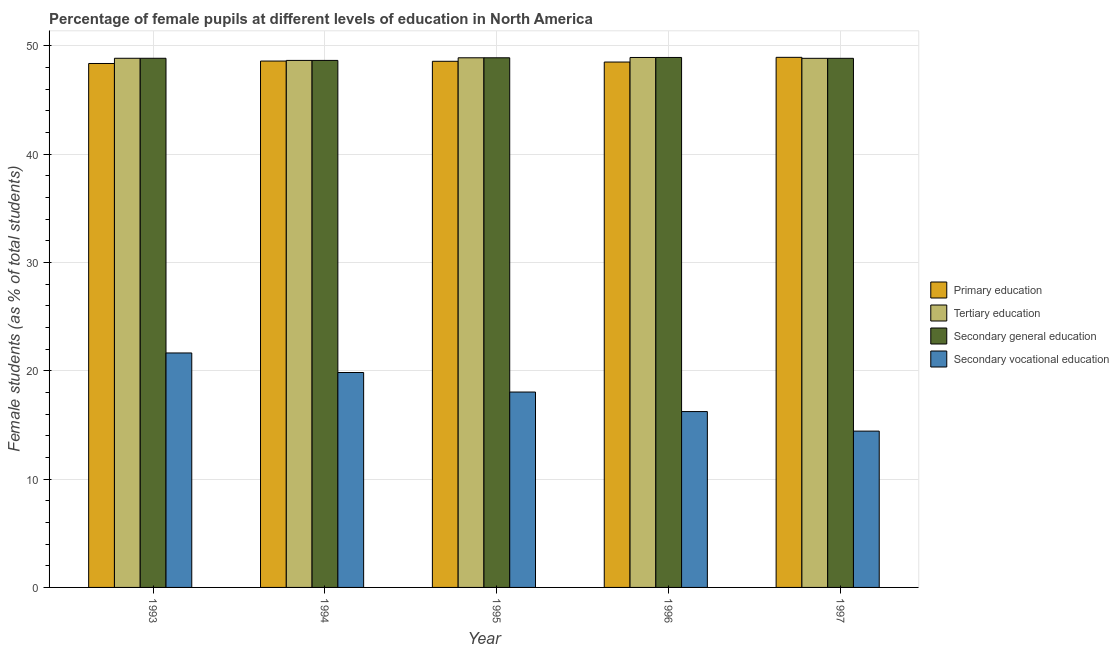How many different coloured bars are there?
Keep it short and to the point. 4. Are the number of bars per tick equal to the number of legend labels?
Give a very brief answer. Yes. Are the number of bars on each tick of the X-axis equal?
Offer a very short reply. Yes. How many bars are there on the 5th tick from the left?
Give a very brief answer. 4. How many bars are there on the 2nd tick from the right?
Your answer should be very brief. 4. What is the label of the 2nd group of bars from the left?
Give a very brief answer. 1994. In how many cases, is the number of bars for a given year not equal to the number of legend labels?
Your response must be concise. 0. What is the percentage of female students in secondary vocational education in 1994?
Your response must be concise. 19.84. Across all years, what is the maximum percentage of female students in secondary education?
Ensure brevity in your answer.  48.93. Across all years, what is the minimum percentage of female students in secondary education?
Provide a succinct answer. 48.66. What is the total percentage of female students in secondary education in the graph?
Give a very brief answer. 244.21. What is the difference between the percentage of female students in secondary vocational education in 1993 and that in 1994?
Provide a succinct answer. 1.8. What is the difference between the percentage of female students in secondary vocational education in 1995 and the percentage of female students in secondary education in 1996?
Provide a succinct answer. 1.8. What is the average percentage of female students in primary education per year?
Your response must be concise. 48.6. In the year 1993, what is the difference between the percentage of female students in secondary education and percentage of female students in primary education?
Offer a terse response. 0. What is the ratio of the percentage of female students in primary education in 1993 to that in 1995?
Your answer should be compact. 1. Is the difference between the percentage of female students in tertiary education in 1994 and 1997 greater than the difference between the percentage of female students in secondary vocational education in 1994 and 1997?
Offer a terse response. No. What is the difference between the highest and the second highest percentage of female students in secondary education?
Give a very brief answer. 0.03. What is the difference between the highest and the lowest percentage of female students in primary education?
Offer a very short reply. 0.57. What does the 4th bar from the left in 1997 represents?
Your response must be concise. Secondary vocational education. What does the 1st bar from the right in 1997 represents?
Ensure brevity in your answer.  Secondary vocational education. How many bars are there?
Ensure brevity in your answer.  20. How many years are there in the graph?
Give a very brief answer. 5. What is the title of the graph?
Offer a terse response. Percentage of female pupils at different levels of education in North America. Does "Korea" appear as one of the legend labels in the graph?
Keep it short and to the point. No. What is the label or title of the X-axis?
Keep it short and to the point. Year. What is the label or title of the Y-axis?
Make the answer very short. Female students (as % of total students). What is the Female students (as % of total students) in Primary education in 1993?
Your response must be concise. 48.38. What is the Female students (as % of total students) of Tertiary education in 1993?
Offer a terse response. 48.86. What is the Female students (as % of total students) in Secondary general education in 1993?
Make the answer very short. 48.86. What is the Female students (as % of total students) of Secondary vocational education in 1993?
Make the answer very short. 21.65. What is the Female students (as % of total students) in Primary education in 1994?
Your response must be concise. 48.6. What is the Female students (as % of total students) of Tertiary education in 1994?
Your response must be concise. 48.66. What is the Female students (as % of total students) in Secondary general education in 1994?
Make the answer very short. 48.66. What is the Female students (as % of total students) of Secondary vocational education in 1994?
Your answer should be compact. 19.84. What is the Female students (as % of total students) in Primary education in 1995?
Make the answer very short. 48.58. What is the Female students (as % of total students) in Tertiary education in 1995?
Offer a very short reply. 48.9. What is the Female students (as % of total students) in Secondary general education in 1995?
Make the answer very short. 48.9. What is the Female students (as % of total students) of Secondary vocational education in 1995?
Provide a short and direct response. 18.04. What is the Female students (as % of total students) in Primary education in 1996?
Offer a very short reply. 48.51. What is the Female students (as % of total students) in Tertiary education in 1996?
Give a very brief answer. 48.93. What is the Female students (as % of total students) of Secondary general education in 1996?
Offer a terse response. 48.93. What is the Female students (as % of total students) in Secondary vocational education in 1996?
Offer a very short reply. 16.24. What is the Female students (as % of total students) of Primary education in 1997?
Offer a very short reply. 48.95. What is the Female students (as % of total students) in Tertiary education in 1997?
Offer a terse response. 48.85. What is the Female students (as % of total students) in Secondary general education in 1997?
Offer a very short reply. 48.85. What is the Female students (as % of total students) in Secondary vocational education in 1997?
Keep it short and to the point. 14.43. Across all years, what is the maximum Female students (as % of total students) of Primary education?
Keep it short and to the point. 48.95. Across all years, what is the maximum Female students (as % of total students) of Tertiary education?
Keep it short and to the point. 48.93. Across all years, what is the maximum Female students (as % of total students) of Secondary general education?
Make the answer very short. 48.93. Across all years, what is the maximum Female students (as % of total students) in Secondary vocational education?
Your answer should be compact. 21.65. Across all years, what is the minimum Female students (as % of total students) of Primary education?
Your answer should be very brief. 48.38. Across all years, what is the minimum Female students (as % of total students) of Tertiary education?
Make the answer very short. 48.66. Across all years, what is the minimum Female students (as % of total students) in Secondary general education?
Your response must be concise. 48.66. Across all years, what is the minimum Female students (as % of total students) in Secondary vocational education?
Your response must be concise. 14.43. What is the total Female students (as % of total students) in Primary education in the graph?
Keep it short and to the point. 243.01. What is the total Female students (as % of total students) in Tertiary education in the graph?
Provide a succinct answer. 244.21. What is the total Female students (as % of total students) in Secondary general education in the graph?
Provide a succinct answer. 244.21. What is the total Female students (as % of total students) of Secondary vocational education in the graph?
Your response must be concise. 90.2. What is the difference between the Female students (as % of total students) in Primary education in 1993 and that in 1994?
Offer a very short reply. -0.23. What is the difference between the Female students (as % of total students) in Tertiary education in 1993 and that in 1994?
Provide a succinct answer. 0.2. What is the difference between the Female students (as % of total students) of Secondary general education in 1993 and that in 1994?
Your answer should be very brief. 0.2. What is the difference between the Female students (as % of total students) in Secondary vocational education in 1993 and that in 1994?
Your answer should be very brief. 1.8. What is the difference between the Female students (as % of total students) of Primary education in 1993 and that in 1995?
Offer a very short reply. -0.2. What is the difference between the Female students (as % of total students) of Tertiary education in 1993 and that in 1995?
Give a very brief answer. -0.05. What is the difference between the Female students (as % of total students) in Secondary general education in 1993 and that in 1995?
Offer a terse response. -0.05. What is the difference between the Female students (as % of total students) in Secondary vocational education in 1993 and that in 1995?
Your answer should be very brief. 3.61. What is the difference between the Female students (as % of total students) in Primary education in 1993 and that in 1996?
Your answer should be very brief. -0.13. What is the difference between the Female students (as % of total students) in Tertiary education in 1993 and that in 1996?
Your response must be concise. -0.07. What is the difference between the Female students (as % of total students) of Secondary general education in 1993 and that in 1996?
Give a very brief answer. -0.07. What is the difference between the Female students (as % of total students) of Secondary vocational education in 1993 and that in 1996?
Give a very brief answer. 5.41. What is the difference between the Female students (as % of total students) of Primary education in 1993 and that in 1997?
Keep it short and to the point. -0.57. What is the difference between the Female students (as % of total students) in Tertiary education in 1993 and that in 1997?
Keep it short and to the point. 0.01. What is the difference between the Female students (as % of total students) in Secondary general education in 1993 and that in 1997?
Make the answer very short. 0.01. What is the difference between the Female students (as % of total students) in Secondary vocational education in 1993 and that in 1997?
Offer a very short reply. 7.22. What is the difference between the Female students (as % of total students) of Primary education in 1994 and that in 1995?
Your answer should be very brief. 0.02. What is the difference between the Female students (as % of total students) of Tertiary education in 1994 and that in 1995?
Provide a short and direct response. -0.24. What is the difference between the Female students (as % of total students) of Secondary general education in 1994 and that in 1995?
Provide a succinct answer. -0.24. What is the difference between the Female students (as % of total students) in Secondary vocational education in 1994 and that in 1995?
Give a very brief answer. 1.8. What is the difference between the Female students (as % of total students) of Primary education in 1994 and that in 1996?
Offer a very short reply. 0.09. What is the difference between the Female students (as % of total students) in Tertiary education in 1994 and that in 1996?
Ensure brevity in your answer.  -0.27. What is the difference between the Female students (as % of total students) in Secondary general education in 1994 and that in 1996?
Keep it short and to the point. -0.27. What is the difference between the Female students (as % of total students) of Secondary vocational education in 1994 and that in 1996?
Provide a succinct answer. 3.61. What is the difference between the Female students (as % of total students) in Primary education in 1994 and that in 1997?
Your answer should be compact. -0.34. What is the difference between the Female students (as % of total students) of Tertiary education in 1994 and that in 1997?
Your answer should be compact. -0.19. What is the difference between the Female students (as % of total students) in Secondary general education in 1994 and that in 1997?
Your answer should be compact. -0.19. What is the difference between the Female students (as % of total students) of Secondary vocational education in 1994 and that in 1997?
Your answer should be very brief. 5.41. What is the difference between the Female students (as % of total students) in Primary education in 1995 and that in 1996?
Ensure brevity in your answer.  0.07. What is the difference between the Female students (as % of total students) in Tertiary education in 1995 and that in 1996?
Keep it short and to the point. -0.03. What is the difference between the Female students (as % of total students) of Secondary general education in 1995 and that in 1996?
Give a very brief answer. -0.03. What is the difference between the Female students (as % of total students) of Secondary vocational education in 1995 and that in 1996?
Your answer should be very brief. 1.8. What is the difference between the Female students (as % of total students) of Primary education in 1995 and that in 1997?
Your answer should be very brief. -0.37. What is the difference between the Female students (as % of total students) of Tertiary education in 1995 and that in 1997?
Your response must be concise. 0.05. What is the difference between the Female students (as % of total students) of Secondary general education in 1995 and that in 1997?
Provide a short and direct response. 0.05. What is the difference between the Female students (as % of total students) in Secondary vocational education in 1995 and that in 1997?
Give a very brief answer. 3.61. What is the difference between the Female students (as % of total students) of Primary education in 1996 and that in 1997?
Provide a succinct answer. -0.43. What is the difference between the Female students (as % of total students) in Tertiary education in 1996 and that in 1997?
Offer a terse response. 0.08. What is the difference between the Female students (as % of total students) in Secondary general education in 1996 and that in 1997?
Make the answer very short. 0.08. What is the difference between the Female students (as % of total students) of Secondary vocational education in 1996 and that in 1997?
Ensure brevity in your answer.  1.8. What is the difference between the Female students (as % of total students) of Primary education in 1993 and the Female students (as % of total students) of Tertiary education in 1994?
Provide a succinct answer. -0.28. What is the difference between the Female students (as % of total students) of Primary education in 1993 and the Female students (as % of total students) of Secondary general education in 1994?
Your response must be concise. -0.28. What is the difference between the Female students (as % of total students) of Primary education in 1993 and the Female students (as % of total students) of Secondary vocational education in 1994?
Offer a very short reply. 28.53. What is the difference between the Female students (as % of total students) in Tertiary education in 1993 and the Female students (as % of total students) in Secondary general education in 1994?
Your answer should be very brief. 0.2. What is the difference between the Female students (as % of total students) in Tertiary education in 1993 and the Female students (as % of total students) in Secondary vocational education in 1994?
Your answer should be very brief. 29.01. What is the difference between the Female students (as % of total students) in Secondary general education in 1993 and the Female students (as % of total students) in Secondary vocational education in 1994?
Provide a succinct answer. 29.01. What is the difference between the Female students (as % of total students) of Primary education in 1993 and the Female students (as % of total students) of Tertiary education in 1995?
Offer a very short reply. -0.53. What is the difference between the Female students (as % of total students) of Primary education in 1993 and the Female students (as % of total students) of Secondary general education in 1995?
Offer a terse response. -0.53. What is the difference between the Female students (as % of total students) in Primary education in 1993 and the Female students (as % of total students) in Secondary vocational education in 1995?
Give a very brief answer. 30.34. What is the difference between the Female students (as % of total students) in Tertiary education in 1993 and the Female students (as % of total students) in Secondary general education in 1995?
Provide a short and direct response. -0.05. What is the difference between the Female students (as % of total students) in Tertiary education in 1993 and the Female students (as % of total students) in Secondary vocational education in 1995?
Keep it short and to the point. 30.82. What is the difference between the Female students (as % of total students) in Secondary general education in 1993 and the Female students (as % of total students) in Secondary vocational education in 1995?
Offer a terse response. 30.82. What is the difference between the Female students (as % of total students) of Primary education in 1993 and the Female students (as % of total students) of Tertiary education in 1996?
Your response must be concise. -0.56. What is the difference between the Female students (as % of total students) of Primary education in 1993 and the Female students (as % of total students) of Secondary general education in 1996?
Keep it short and to the point. -0.56. What is the difference between the Female students (as % of total students) of Primary education in 1993 and the Female students (as % of total students) of Secondary vocational education in 1996?
Your response must be concise. 32.14. What is the difference between the Female students (as % of total students) of Tertiary education in 1993 and the Female students (as % of total students) of Secondary general education in 1996?
Your response must be concise. -0.07. What is the difference between the Female students (as % of total students) of Tertiary education in 1993 and the Female students (as % of total students) of Secondary vocational education in 1996?
Offer a terse response. 32.62. What is the difference between the Female students (as % of total students) of Secondary general education in 1993 and the Female students (as % of total students) of Secondary vocational education in 1996?
Give a very brief answer. 32.62. What is the difference between the Female students (as % of total students) of Primary education in 1993 and the Female students (as % of total students) of Tertiary education in 1997?
Make the answer very short. -0.48. What is the difference between the Female students (as % of total students) of Primary education in 1993 and the Female students (as % of total students) of Secondary general education in 1997?
Your response must be concise. -0.48. What is the difference between the Female students (as % of total students) in Primary education in 1993 and the Female students (as % of total students) in Secondary vocational education in 1997?
Ensure brevity in your answer.  33.94. What is the difference between the Female students (as % of total students) in Tertiary education in 1993 and the Female students (as % of total students) in Secondary general education in 1997?
Your response must be concise. 0.01. What is the difference between the Female students (as % of total students) in Tertiary education in 1993 and the Female students (as % of total students) in Secondary vocational education in 1997?
Offer a terse response. 34.43. What is the difference between the Female students (as % of total students) of Secondary general education in 1993 and the Female students (as % of total students) of Secondary vocational education in 1997?
Offer a terse response. 34.43. What is the difference between the Female students (as % of total students) of Primary education in 1994 and the Female students (as % of total students) of Tertiary education in 1995?
Make the answer very short. -0.3. What is the difference between the Female students (as % of total students) of Primary education in 1994 and the Female students (as % of total students) of Secondary general education in 1995?
Provide a short and direct response. -0.3. What is the difference between the Female students (as % of total students) of Primary education in 1994 and the Female students (as % of total students) of Secondary vocational education in 1995?
Provide a succinct answer. 30.56. What is the difference between the Female students (as % of total students) of Tertiary education in 1994 and the Female students (as % of total students) of Secondary general education in 1995?
Ensure brevity in your answer.  -0.24. What is the difference between the Female students (as % of total students) of Tertiary education in 1994 and the Female students (as % of total students) of Secondary vocational education in 1995?
Ensure brevity in your answer.  30.62. What is the difference between the Female students (as % of total students) of Secondary general education in 1994 and the Female students (as % of total students) of Secondary vocational education in 1995?
Your response must be concise. 30.62. What is the difference between the Female students (as % of total students) of Primary education in 1994 and the Female students (as % of total students) of Tertiary education in 1996?
Make the answer very short. -0.33. What is the difference between the Female students (as % of total students) of Primary education in 1994 and the Female students (as % of total students) of Secondary general education in 1996?
Offer a terse response. -0.33. What is the difference between the Female students (as % of total students) of Primary education in 1994 and the Female students (as % of total students) of Secondary vocational education in 1996?
Ensure brevity in your answer.  32.37. What is the difference between the Female students (as % of total students) of Tertiary education in 1994 and the Female students (as % of total students) of Secondary general education in 1996?
Keep it short and to the point. -0.27. What is the difference between the Female students (as % of total students) of Tertiary education in 1994 and the Female students (as % of total students) of Secondary vocational education in 1996?
Provide a succinct answer. 32.42. What is the difference between the Female students (as % of total students) of Secondary general education in 1994 and the Female students (as % of total students) of Secondary vocational education in 1996?
Provide a succinct answer. 32.42. What is the difference between the Female students (as % of total students) in Primary education in 1994 and the Female students (as % of total students) in Tertiary education in 1997?
Provide a short and direct response. -0.25. What is the difference between the Female students (as % of total students) of Primary education in 1994 and the Female students (as % of total students) of Secondary general education in 1997?
Give a very brief answer. -0.25. What is the difference between the Female students (as % of total students) of Primary education in 1994 and the Female students (as % of total students) of Secondary vocational education in 1997?
Provide a short and direct response. 34.17. What is the difference between the Female students (as % of total students) in Tertiary education in 1994 and the Female students (as % of total students) in Secondary general education in 1997?
Keep it short and to the point. -0.19. What is the difference between the Female students (as % of total students) in Tertiary education in 1994 and the Female students (as % of total students) in Secondary vocational education in 1997?
Your answer should be compact. 34.23. What is the difference between the Female students (as % of total students) in Secondary general education in 1994 and the Female students (as % of total students) in Secondary vocational education in 1997?
Keep it short and to the point. 34.23. What is the difference between the Female students (as % of total students) in Primary education in 1995 and the Female students (as % of total students) in Tertiary education in 1996?
Your response must be concise. -0.35. What is the difference between the Female students (as % of total students) of Primary education in 1995 and the Female students (as % of total students) of Secondary general education in 1996?
Ensure brevity in your answer.  -0.35. What is the difference between the Female students (as % of total students) of Primary education in 1995 and the Female students (as % of total students) of Secondary vocational education in 1996?
Ensure brevity in your answer.  32.34. What is the difference between the Female students (as % of total students) of Tertiary education in 1995 and the Female students (as % of total students) of Secondary general education in 1996?
Provide a succinct answer. -0.03. What is the difference between the Female students (as % of total students) in Tertiary education in 1995 and the Female students (as % of total students) in Secondary vocational education in 1996?
Offer a terse response. 32.67. What is the difference between the Female students (as % of total students) of Secondary general education in 1995 and the Female students (as % of total students) of Secondary vocational education in 1996?
Make the answer very short. 32.67. What is the difference between the Female students (as % of total students) of Primary education in 1995 and the Female students (as % of total students) of Tertiary education in 1997?
Give a very brief answer. -0.27. What is the difference between the Female students (as % of total students) of Primary education in 1995 and the Female students (as % of total students) of Secondary general education in 1997?
Keep it short and to the point. -0.27. What is the difference between the Female students (as % of total students) of Primary education in 1995 and the Female students (as % of total students) of Secondary vocational education in 1997?
Make the answer very short. 34.15. What is the difference between the Female students (as % of total students) in Tertiary education in 1995 and the Female students (as % of total students) in Secondary general education in 1997?
Offer a very short reply. 0.05. What is the difference between the Female students (as % of total students) of Tertiary education in 1995 and the Female students (as % of total students) of Secondary vocational education in 1997?
Your answer should be very brief. 34.47. What is the difference between the Female students (as % of total students) of Secondary general education in 1995 and the Female students (as % of total students) of Secondary vocational education in 1997?
Your response must be concise. 34.47. What is the difference between the Female students (as % of total students) of Primary education in 1996 and the Female students (as % of total students) of Tertiary education in 1997?
Make the answer very short. -0.34. What is the difference between the Female students (as % of total students) of Primary education in 1996 and the Female students (as % of total students) of Secondary general education in 1997?
Give a very brief answer. -0.34. What is the difference between the Female students (as % of total students) in Primary education in 1996 and the Female students (as % of total students) in Secondary vocational education in 1997?
Offer a very short reply. 34.08. What is the difference between the Female students (as % of total students) of Tertiary education in 1996 and the Female students (as % of total students) of Secondary general education in 1997?
Give a very brief answer. 0.08. What is the difference between the Female students (as % of total students) in Tertiary education in 1996 and the Female students (as % of total students) in Secondary vocational education in 1997?
Your answer should be very brief. 34.5. What is the difference between the Female students (as % of total students) of Secondary general education in 1996 and the Female students (as % of total students) of Secondary vocational education in 1997?
Give a very brief answer. 34.5. What is the average Female students (as % of total students) of Primary education per year?
Your answer should be very brief. 48.6. What is the average Female students (as % of total students) of Tertiary education per year?
Make the answer very short. 48.84. What is the average Female students (as % of total students) of Secondary general education per year?
Keep it short and to the point. 48.84. What is the average Female students (as % of total students) of Secondary vocational education per year?
Provide a short and direct response. 18.04. In the year 1993, what is the difference between the Female students (as % of total students) in Primary education and Female students (as % of total students) in Tertiary education?
Your answer should be very brief. -0.48. In the year 1993, what is the difference between the Female students (as % of total students) of Primary education and Female students (as % of total students) of Secondary general education?
Make the answer very short. -0.48. In the year 1993, what is the difference between the Female students (as % of total students) in Primary education and Female students (as % of total students) in Secondary vocational education?
Offer a terse response. 26.73. In the year 1993, what is the difference between the Female students (as % of total students) of Tertiary education and Female students (as % of total students) of Secondary general education?
Give a very brief answer. -0. In the year 1993, what is the difference between the Female students (as % of total students) of Tertiary education and Female students (as % of total students) of Secondary vocational education?
Keep it short and to the point. 27.21. In the year 1993, what is the difference between the Female students (as % of total students) in Secondary general education and Female students (as % of total students) in Secondary vocational education?
Offer a very short reply. 27.21. In the year 1994, what is the difference between the Female students (as % of total students) in Primary education and Female students (as % of total students) in Tertiary education?
Make the answer very short. -0.06. In the year 1994, what is the difference between the Female students (as % of total students) in Primary education and Female students (as % of total students) in Secondary general education?
Provide a short and direct response. -0.06. In the year 1994, what is the difference between the Female students (as % of total students) of Primary education and Female students (as % of total students) of Secondary vocational education?
Ensure brevity in your answer.  28.76. In the year 1994, what is the difference between the Female students (as % of total students) in Tertiary education and Female students (as % of total students) in Secondary general education?
Ensure brevity in your answer.  -0. In the year 1994, what is the difference between the Female students (as % of total students) in Tertiary education and Female students (as % of total students) in Secondary vocational education?
Your response must be concise. 28.82. In the year 1994, what is the difference between the Female students (as % of total students) in Secondary general education and Female students (as % of total students) in Secondary vocational education?
Make the answer very short. 28.82. In the year 1995, what is the difference between the Female students (as % of total students) of Primary education and Female students (as % of total students) of Tertiary education?
Your answer should be very brief. -0.32. In the year 1995, what is the difference between the Female students (as % of total students) of Primary education and Female students (as % of total students) of Secondary general education?
Your response must be concise. -0.32. In the year 1995, what is the difference between the Female students (as % of total students) in Primary education and Female students (as % of total students) in Secondary vocational education?
Your answer should be compact. 30.54. In the year 1995, what is the difference between the Female students (as % of total students) in Tertiary education and Female students (as % of total students) in Secondary general education?
Offer a terse response. -0. In the year 1995, what is the difference between the Female students (as % of total students) of Tertiary education and Female students (as % of total students) of Secondary vocational education?
Give a very brief answer. 30.86. In the year 1995, what is the difference between the Female students (as % of total students) in Secondary general education and Female students (as % of total students) in Secondary vocational education?
Provide a short and direct response. 30.86. In the year 1996, what is the difference between the Female students (as % of total students) of Primary education and Female students (as % of total students) of Tertiary education?
Give a very brief answer. -0.42. In the year 1996, what is the difference between the Female students (as % of total students) of Primary education and Female students (as % of total students) of Secondary general education?
Offer a terse response. -0.42. In the year 1996, what is the difference between the Female students (as % of total students) of Primary education and Female students (as % of total students) of Secondary vocational education?
Provide a short and direct response. 32.27. In the year 1996, what is the difference between the Female students (as % of total students) of Tertiary education and Female students (as % of total students) of Secondary general education?
Give a very brief answer. -0. In the year 1996, what is the difference between the Female students (as % of total students) of Tertiary education and Female students (as % of total students) of Secondary vocational education?
Keep it short and to the point. 32.7. In the year 1996, what is the difference between the Female students (as % of total students) of Secondary general education and Female students (as % of total students) of Secondary vocational education?
Your answer should be very brief. 32.7. In the year 1997, what is the difference between the Female students (as % of total students) in Primary education and Female students (as % of total students) in Tertiary education?
Make the answer very short. 0.09. In the year 1997, what is the difference between the Female students (as % of total students) in Primary education and Female students (as % of total students) in Secondary general education?
Your answer should be compact. 0.09. In the year 1997, what is the difference between the Female students (as % of total students) of Primary education and Female students (as % of total students) of Secondary vocational education?
Your answer should be compact. 34.51. In the year 1997, what is the difference between the Female students (as % of total students) of Tertiary education and Female students (as % of total students) of Secondary general education?
Your answer should be compact. -0. In the year 1997, what is the difference between the Female students (as % of total students) of Tertiary education and Female students (as % of total students) of Secondary vocational education?
Offer a terse response. 34.42. In the year 1997, what is the difference between the Female students (as % of total students) in Secondary general education and Female students (as % of total students) in Secondary vocational education?
Give a very brief answer. 34.42. What is the ratio of the Female students (as % of total students) in Primary education in 1993 to that in 1994?
Offer a terse response. 1. What is the ratio of the Female students (as % of total students) of Tertiary education in 1993 to that in 1994?
Give a very brief answer. 1. What is the ratio of the Female students (as % of total students) in Secondary general education in 1993 to that in 1994?
Keep it short and to the point. 1. What is the ratio of the Female students (as % of total students) of Tertiary education in 1993 to that in 1995?
Make the answer very short. 1. What is the ratio of the Female students (as % of total students) of Secondary general education in 1993 to that in 1995?
Give a very brief answer. 1. What is the ratio of the Female students (as % of total students) of Secondary vocational education in 1993 to that in 1995?
Provide a short and direct response. 1.2. What is the ratio of the Female students (as % of total students) of Primary education in 1993 to that in 1996?
Offer a very short reply. 1. What is the ratio of the Female students (as % of total students) of Secondary vocational education in 1993 to that in 1996?
Offer a very short reply. 1.33. What is the ratio of the Female students (as % of total students) of Primary education in 1993 to that in 1997?
Provide a succinct answer. 0.99. What is the ratio of the Female students (as % of total students) in Tertiary education in 1993 to that in 1997?
Offer a terse response. 1. What is the ratio of the Female students (as % of total students) in Secondary vocational education in 1993 to that in 1997?
Ensure brevity in your answer.  1.5. What is the ratio of the Female students (as % of total students) of Primary education in 1994 to that in 1995?
Provide a succinct answer. 1. What is the ratio of the Female students (as % of total students) of Secondary vocational education in 1994 to that in 1995?
Provide a short and direct response. 1.1. What is the ratio of the Female students (as % of total students) in Tertiary education in 1994 to that in 1996?
Your answer should be very brief. 0.99. What is the ratio of the Female students (as % of total students) of Secondary general education in 1994 to that in 1996?
Your response must be concise. 0.99. What is the ratio of the Female students (as % of total students) of Secondary vocational education in 1994 to that in 1996?
Ensure brevity in your answer.  1.22. What is the ratio of the Female students (as % of total students) of Tertiary education in 1994 to that in 1997?
Provide a short and direct response. 1. What is the ratio of the Female students (as % of total students) in Secondary general education in 1994 to that in 1997?
Provide a succinct answer. 1. What is the ratio of the Female students (as % of total students) in Secondary vocational education in 1994 to that in 1997?
Provide a short and direct response. 1.38. What is the ratio of the Female students (as % of total students) in Tertiary education in 1995 to that in 1996?
Make the answer very short. 1. What is the ratio of the Female students (as % of total students) of Secondary general education in 1995 to that in 1996?
Your response must be concise. 1. What is the ratio of the Female students (as % of total students) of Secondary vocational education in 1995 to that in 1996?
Provide a succinct answer. 1.11. What is the ratio of the Female students (as % of total students) of Primary education in 1995 to that in 1997?
Ensure brevity in your answer.  0.99. What is the ratio of the Female students (as % of total students) in Primary education in 1996 to that in 1997?
Ensure brevity in your answer.  0.99. What is the difference between the highest and the second highest Female students (as % of total students) of Primary education?
Make the answer very short. 0.34. What is the difference between the highest and the second highest Female students (as % of total students) in Tertiary education?
Offer a very short reply. 0.03. What is the difference between the highest and the second highest Female students (as % of total students) of Secondary general education?
Give a very brief answer. 0.03. What is the difference between the highest and the second highest Female students (as % of total students) in Secondary vocational education?
Give a very brief answer. 1.8. What is the difference between the highest and the lowest Female students (as % of total students) of Primary education?
Your answer should be compact. 0.57. What is the difference between the highest and the lowest Female students (as % of total students) in Tertiary education?
Keep it short and to the point. 0.27. What is the difference between the highest and the lowest Female students (as % of total students) of Secondary general education?
Keep it short and to the point. 0.27. What is the difference between the highest and the lowest Female students (as % of total students) in Secondary vocational education?
Offer a terse response. 7.22. 